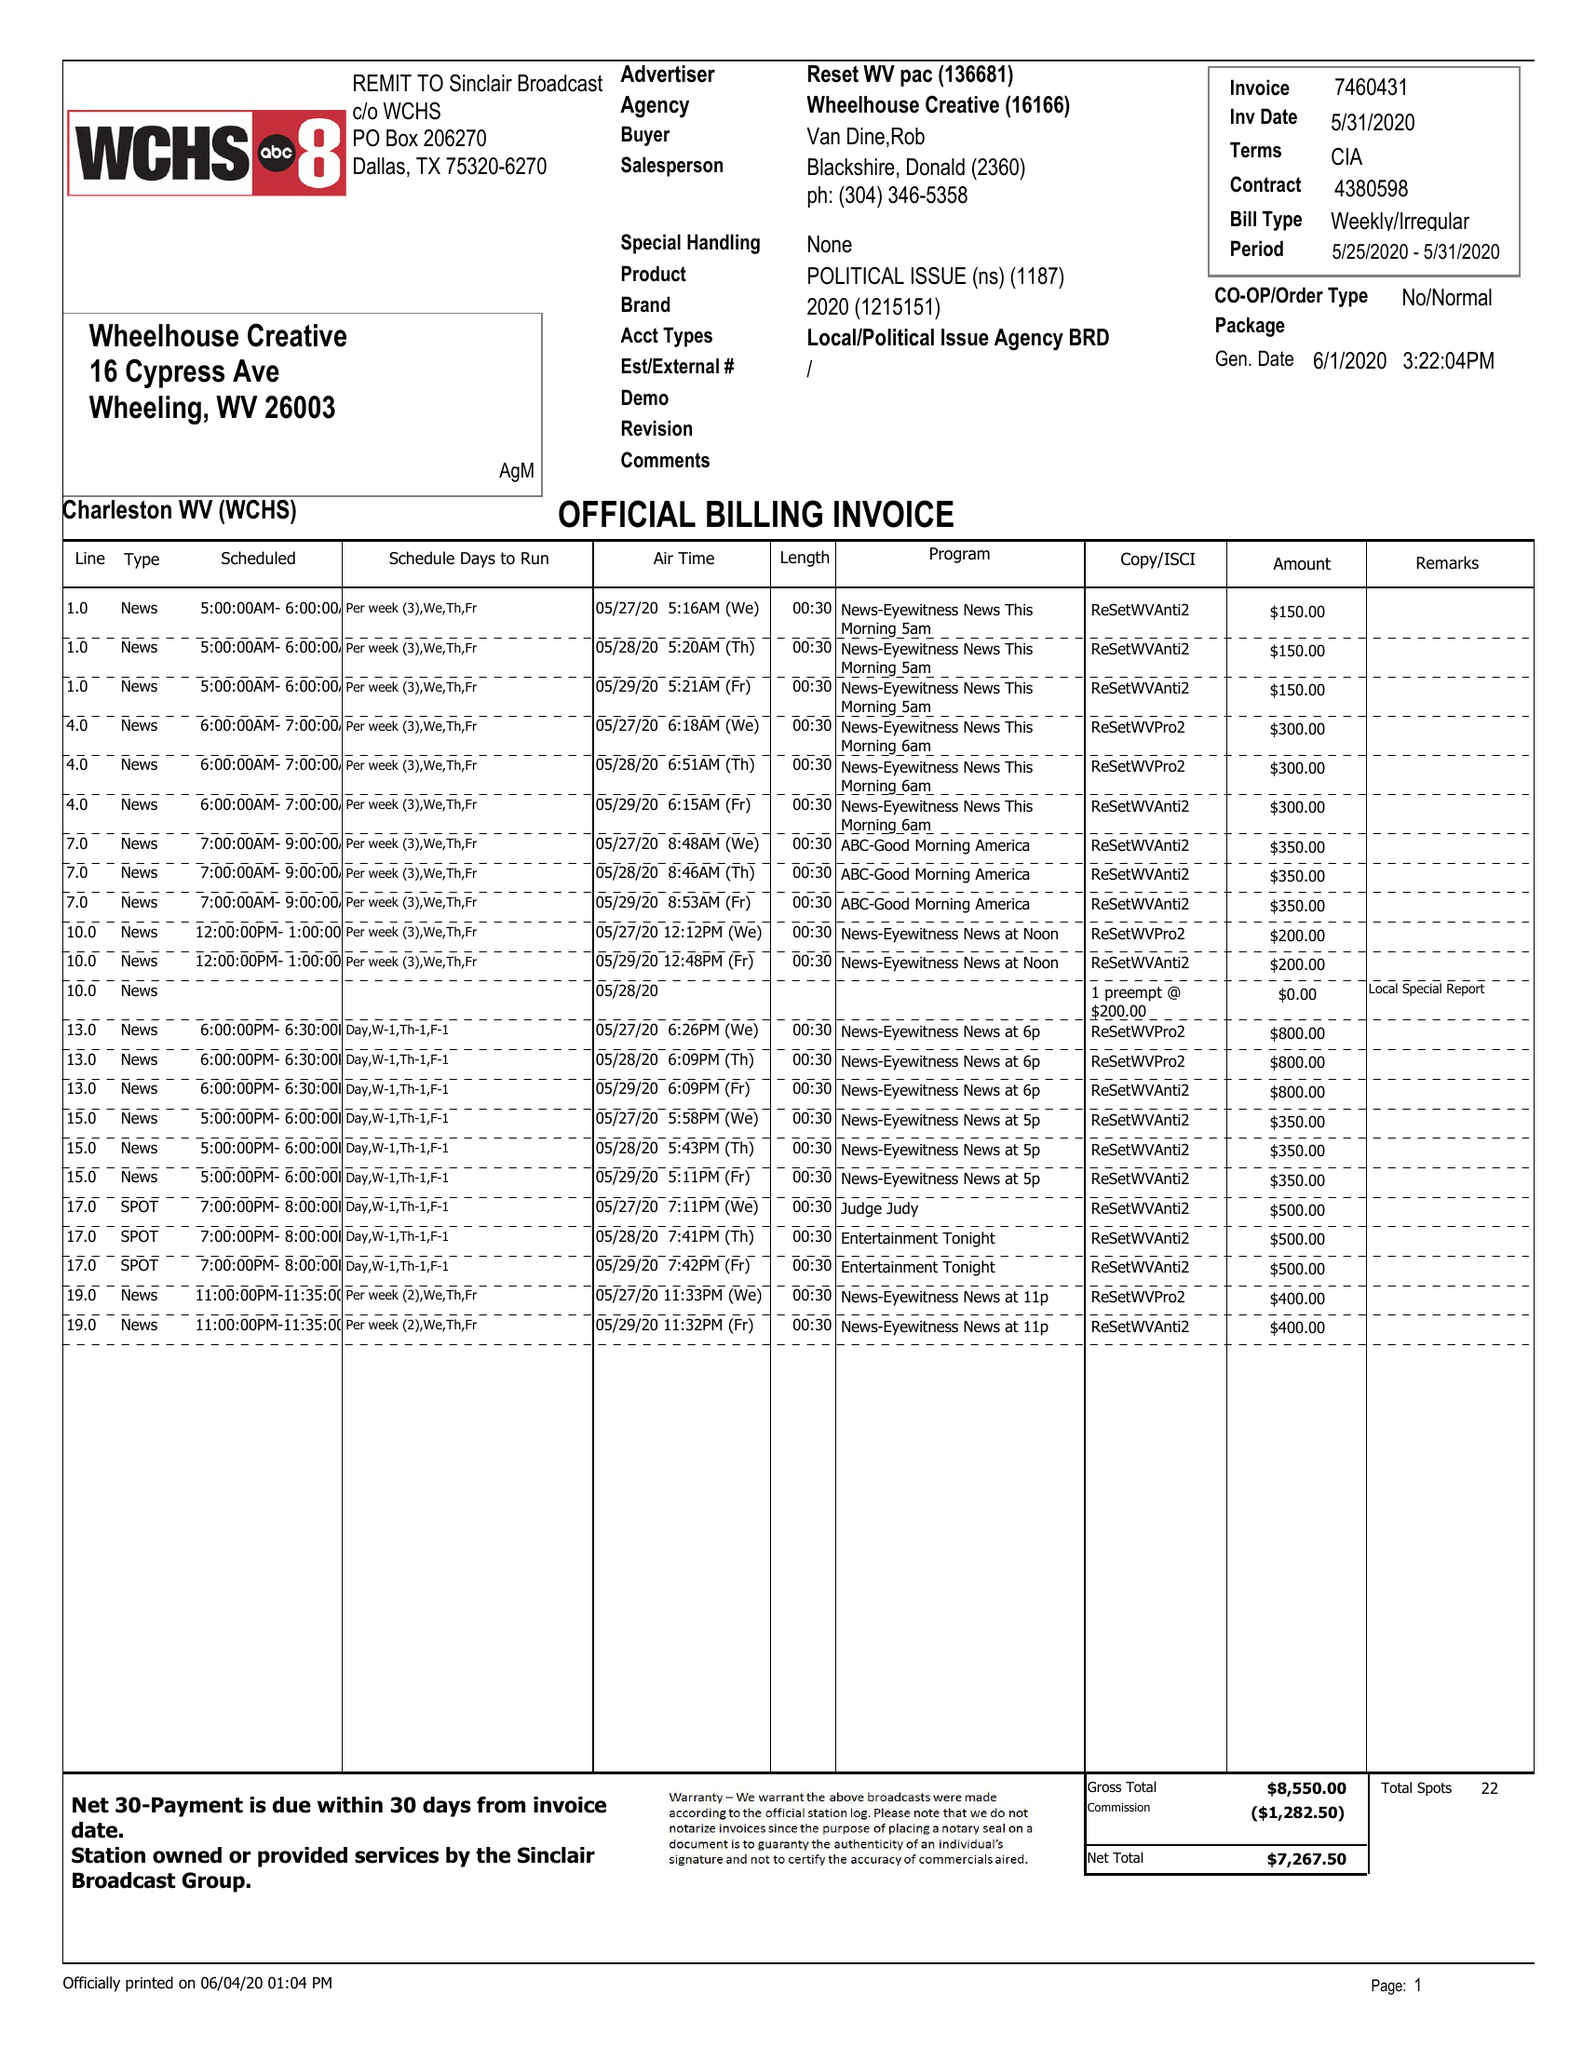What is the value for the advertiser?
Answer the question using a single word or phrase. RESET WV PAC 